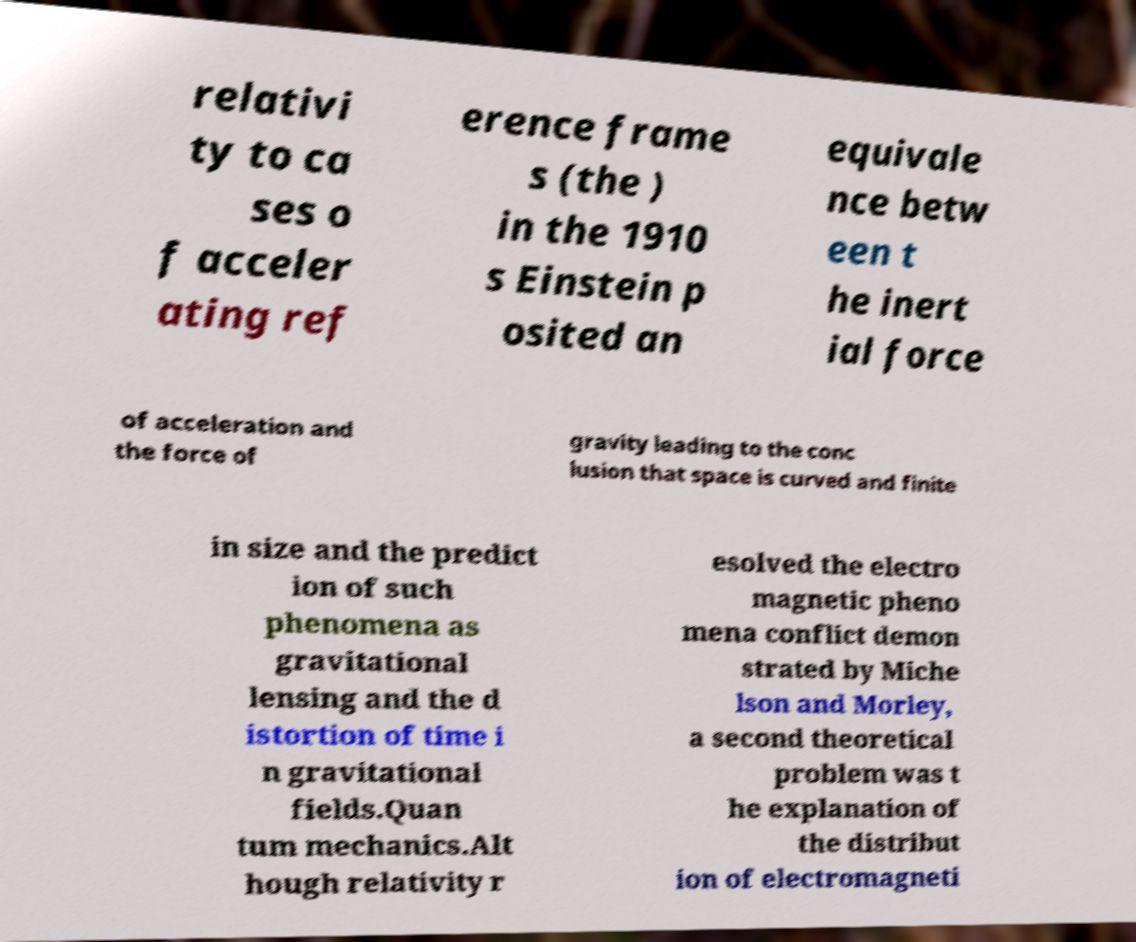Can you read and provide the text displayed in the image?This photo seems to have some interesting text. Can you extract and type it out for me? relativi ty to ca ses o f acceler ating ref erence frame s (the ) in the 1910 s Einstein p osited an equivale nce betw een t he inert ial force of acceleration and the force of gravity leading to the conc lusion that space is curved and finite in size and the predict ion of such phenomena as gravitational lensing and the d istortion of time i n gravitational fields.Quan tum mechanics.Alt hough relativity r esolved the electro magnetic pheno mena conflict demon strated by Miche lson and Morley, a second theoretical problem was t he explanation of the distribut ion of electromagneti 